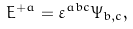<formula> <loc_0><loc_0><loc_500><loc_500>E ^ { + a } = \varepsilon ^ { a b c } \Psi _ { b , c } ,</formula> 